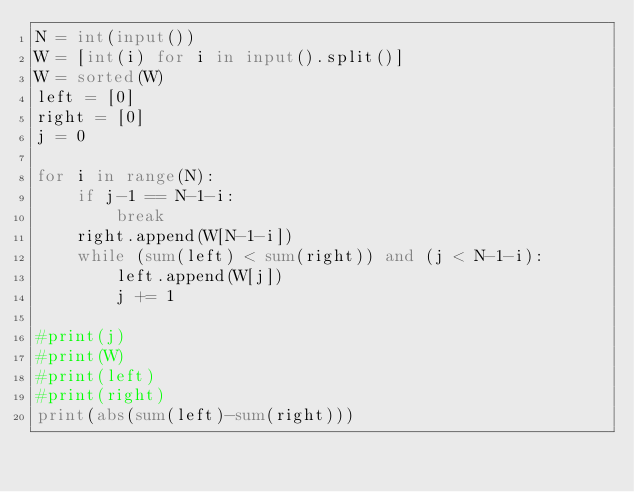<code> <loc_0><loc_0><loc_500><loc_500><_Python_>N = int(input())
W = [int(i) for i in input().split()]
W = sorted(W)
left = [0]
right = [0]
j = 0

for i in range(N):
    if j-1 == N-1-i:
        break
    right.append(W[N-1-i])
    while (sum(left) < sum(right)) and (j < N-1-i):
        left.append(W[j])
        j += 1

#print(j)
#print(W)
#print(left)
#print(right)
print(abs(sum(left)-sum(right)))
    </code> 